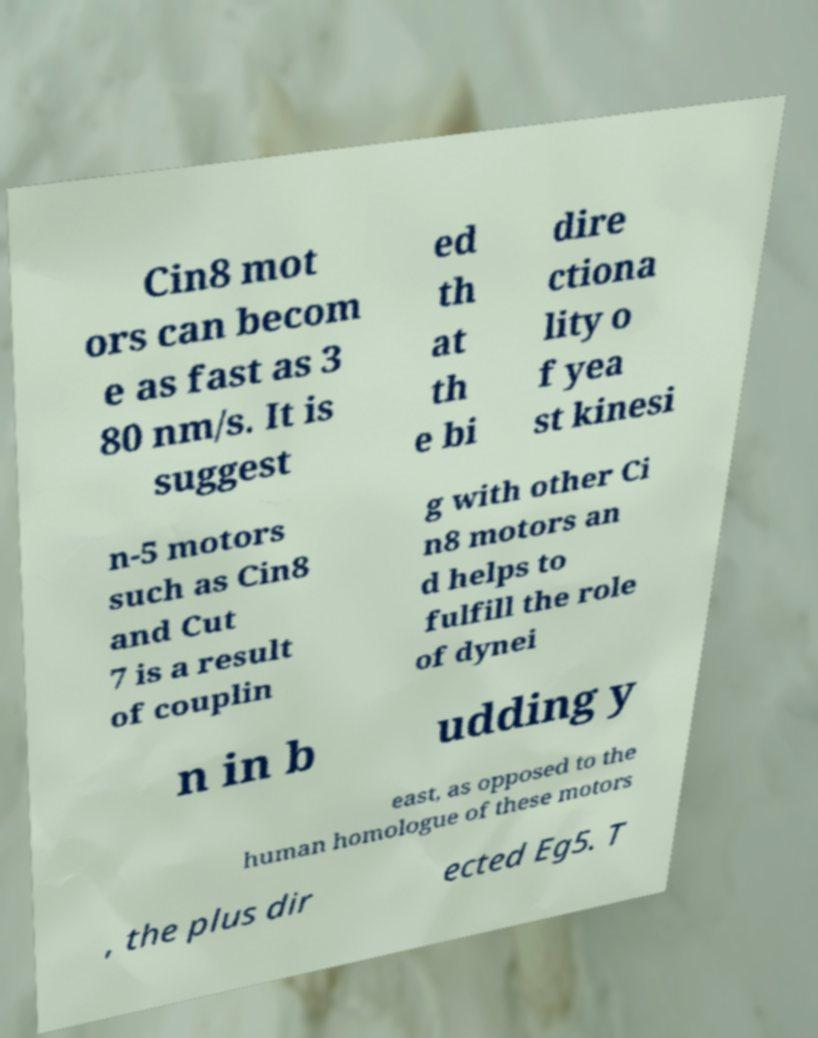Please identify and transcribe the text found in this image. Cin8 mot ors can becom e as fast as 3 80 nm/s. It is suggest ed th at th e bi dire ctiona lity o f yea st kinesi n-5 motors such as Cin8 and Cut 7 is a result of couplin g with other Ci n8 motors an d helps to fulfill the role of dynei n in b udding y east, as opposed to the human homologue of these motors , the plus dir ected Eg5. T 